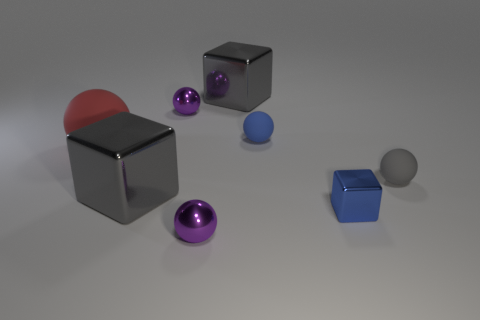There is a big cube that is to the left of the large gray block behind the big sphere; are there any big cubes to the right of it?
Your response must be concise. Yes. What is the color of the big cube in front of the gray metallic cube that is behind the gray ball right of the tiny block?
Give a very brief answer. Gray. There is a tiny blue thing that is the same shape as the small gray thing; what material is it?
Offer a very short reply. Rubber. There is a object in front of the tiny blue metallic thing in front of the blue rubber object; what is its size?
Offer a very short reply. Small. There is a small ball in front of the tiny gray matte object; what is its material?
Keep it short and to the point. Metal. The blue ball that is the same material as the red ball is what size?
Offer a very short reply. Small. How many gray rubber things have the same shape as the red thing?
Offer a very short reply. 1. There is a small blue metallic thing; does it have the same shape as the small rubber thing that is behind the large matte sphere?
Offer a terse response. No. There is a object that is the same color as the tiny block; what is its shape?
Your answer should be very brief. Sphere. Is there a blue block that has the same material as the tiny gray thing?
Make the answer very short. No. 